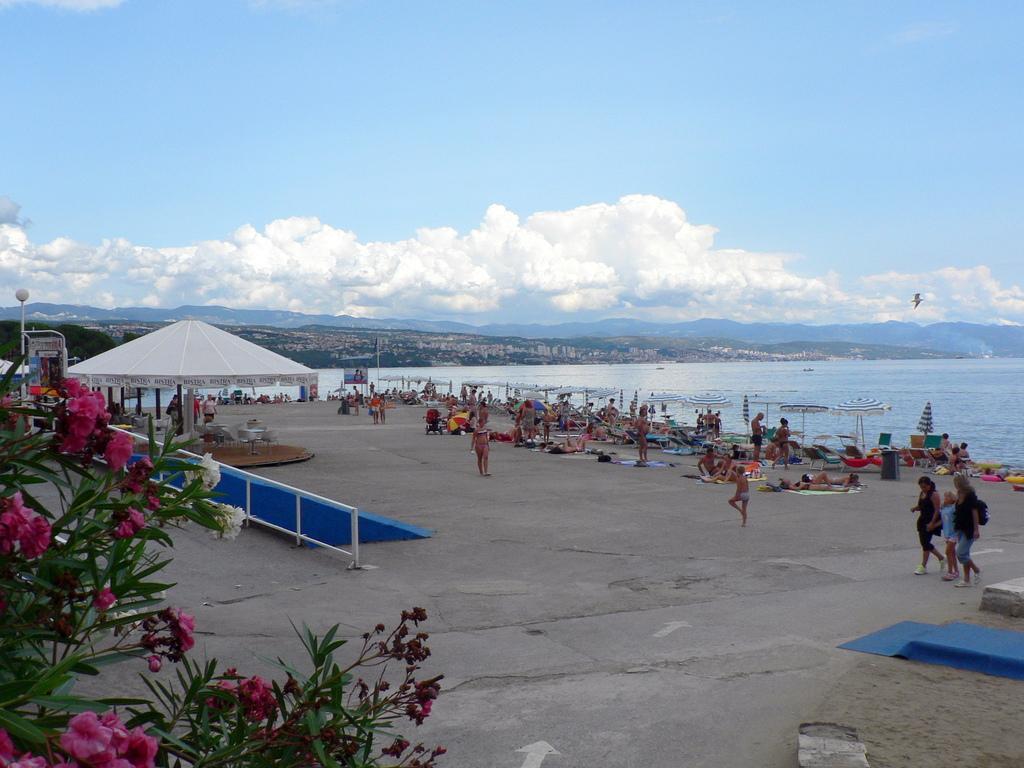In one or two sentences, can you explain what this image depicts? In this image there is a beach area at right side of this image and there a sea at right side to this image and there are some mountains as we can see in middle of this image and there is a cloudy sky at top of this image and there is a bird at right side of this image and there are some persons are resting at the beach area and. There are some trees at bottom left corner of this image and there is an umbrella which is in white color at left side of this image and there are some persons standing at right side of this image. 